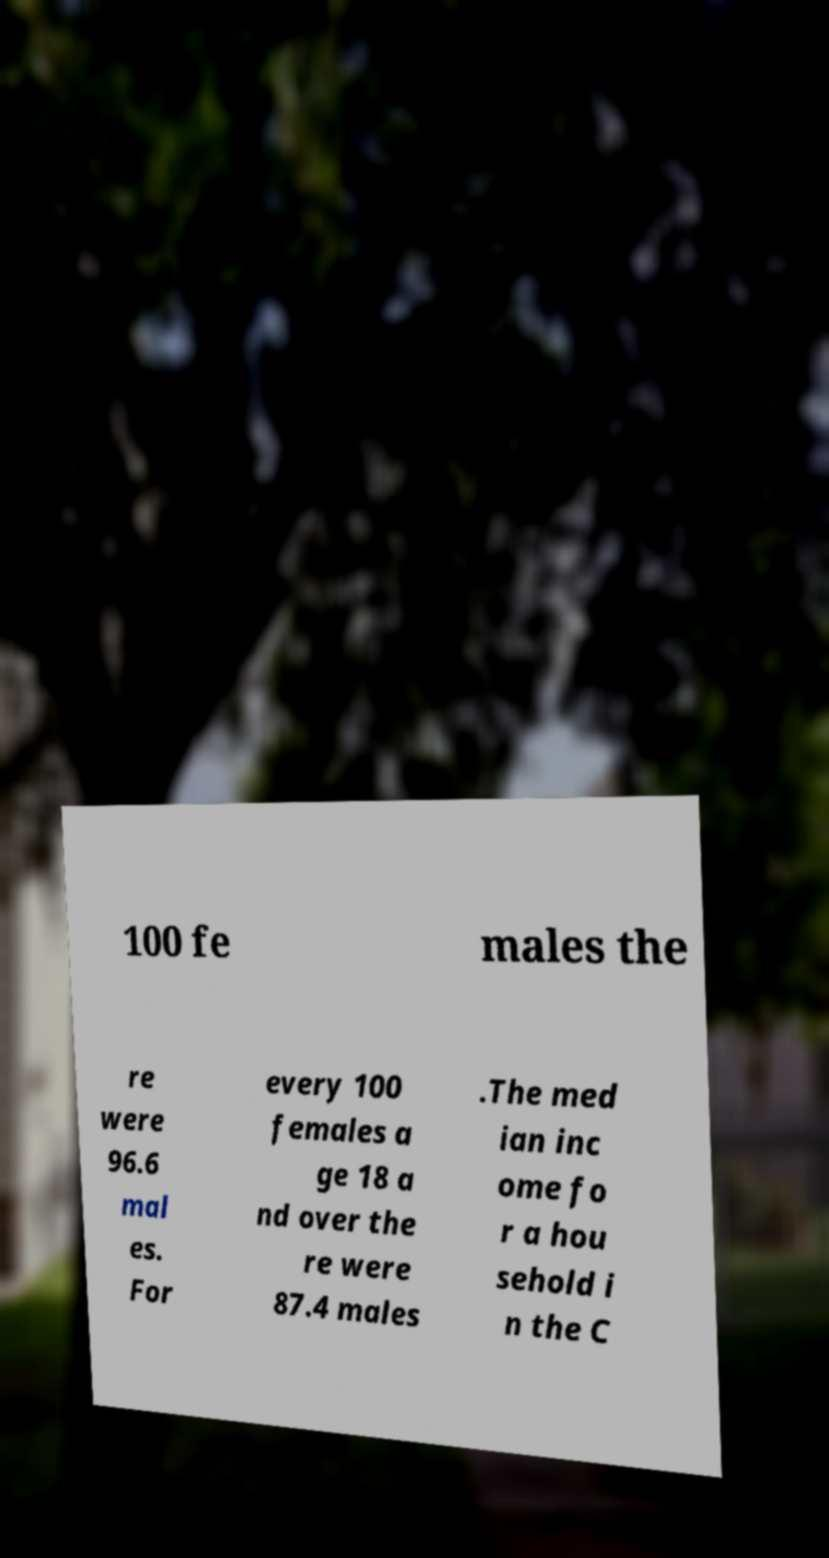Please identify and transcribe the text found in this image. 100 fe males the re were 96.6 mal es. For every 100 females a ge 18 a nd over the re were 87.4 males .The med ian inc ome fo r a hou sehold i n the C 